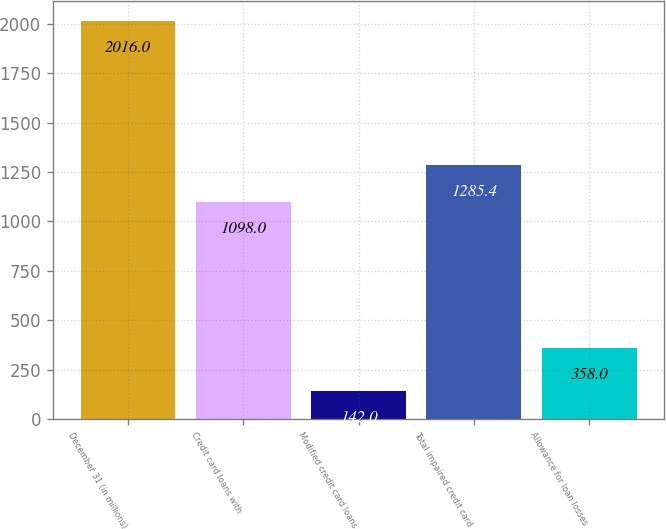Convert chart. <chart><loc_0><loc_0><loc_500><loc_500><bar_chart><fcel>December 31 (in millions)<fcel>Credit card loans with<fcel>Modified credit card loans<fcel>Total impaired credit card<fcel>Allowance for loan losses<nl><fcel>2016<fcel>1098<fcel>142<fcel>1285.4<fcel>358<nl></chart> 